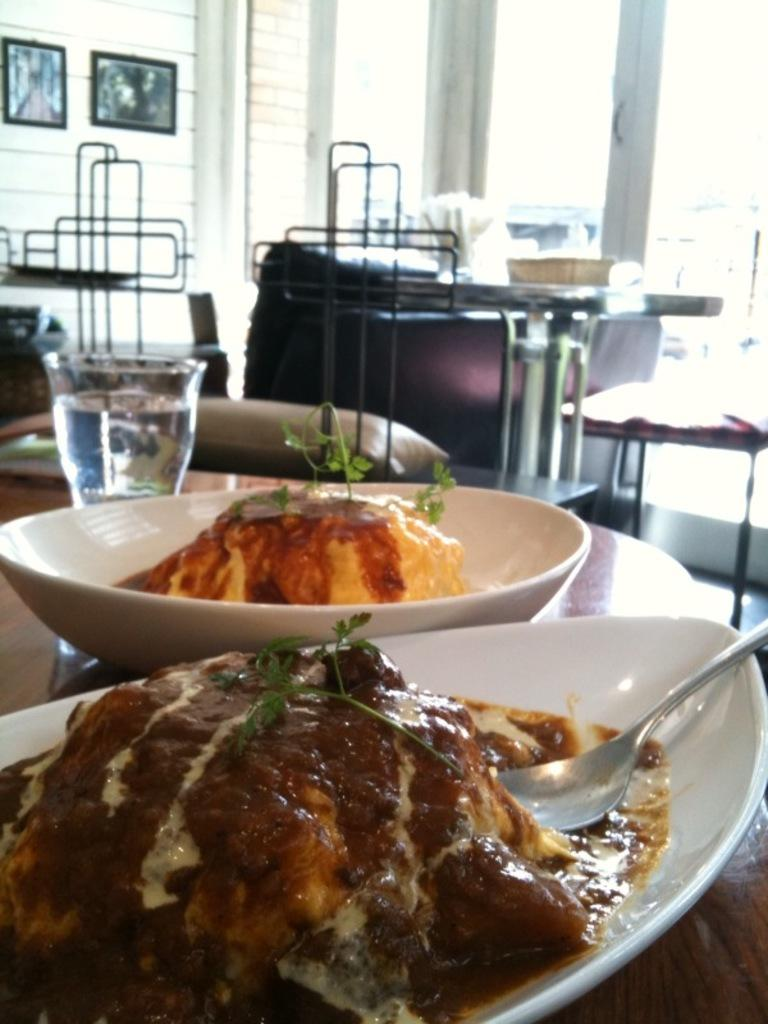What type of food items can be seen in the image? There are food items in bowls in the image. What utensil is present in the image? There is a spoon in the image. What type of beverage is visible in the image? There is a glass of water in the image. Where are the food items and utensils located? The items are on a table. What can be seen in the background of the image? There are chairs, tables, and frames attached to the wall in the background of the image. What type of grain is visible in the image? There is no grain present in the image. Can you see a pen being used in the image? There is no pen visible in the image. 